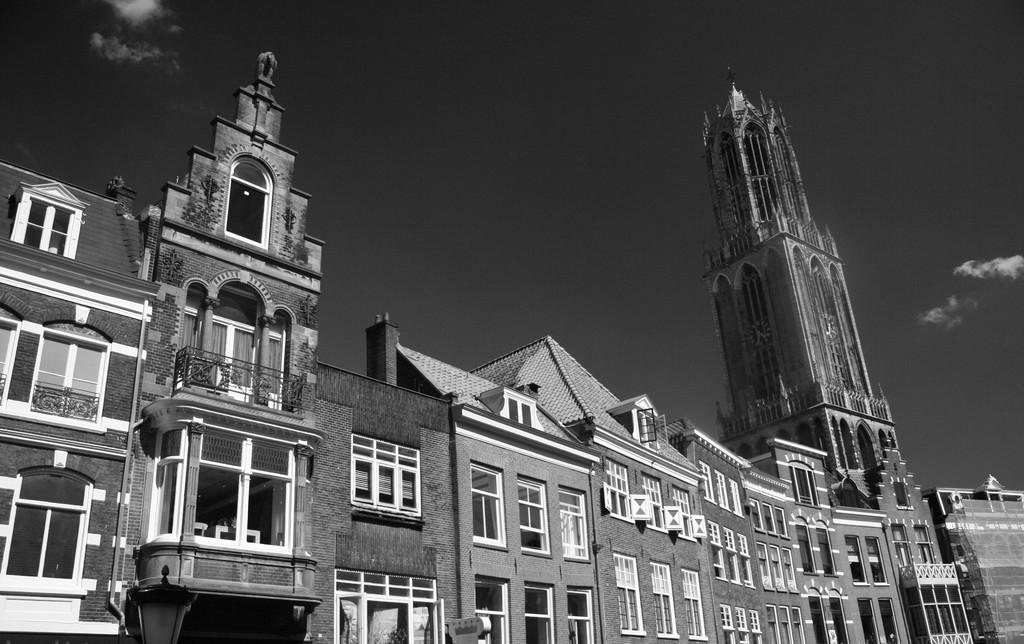What structures are located in the foreground of the image? There are buildings in the foreground of the image. What is visible at the top of the image? The sky is visible at the top of the image. Where is the kettle located in the image? There is no kettle present in the image. What type of love is being expressed in the image? There is no indication of love or any emotion being expressed in the image. 